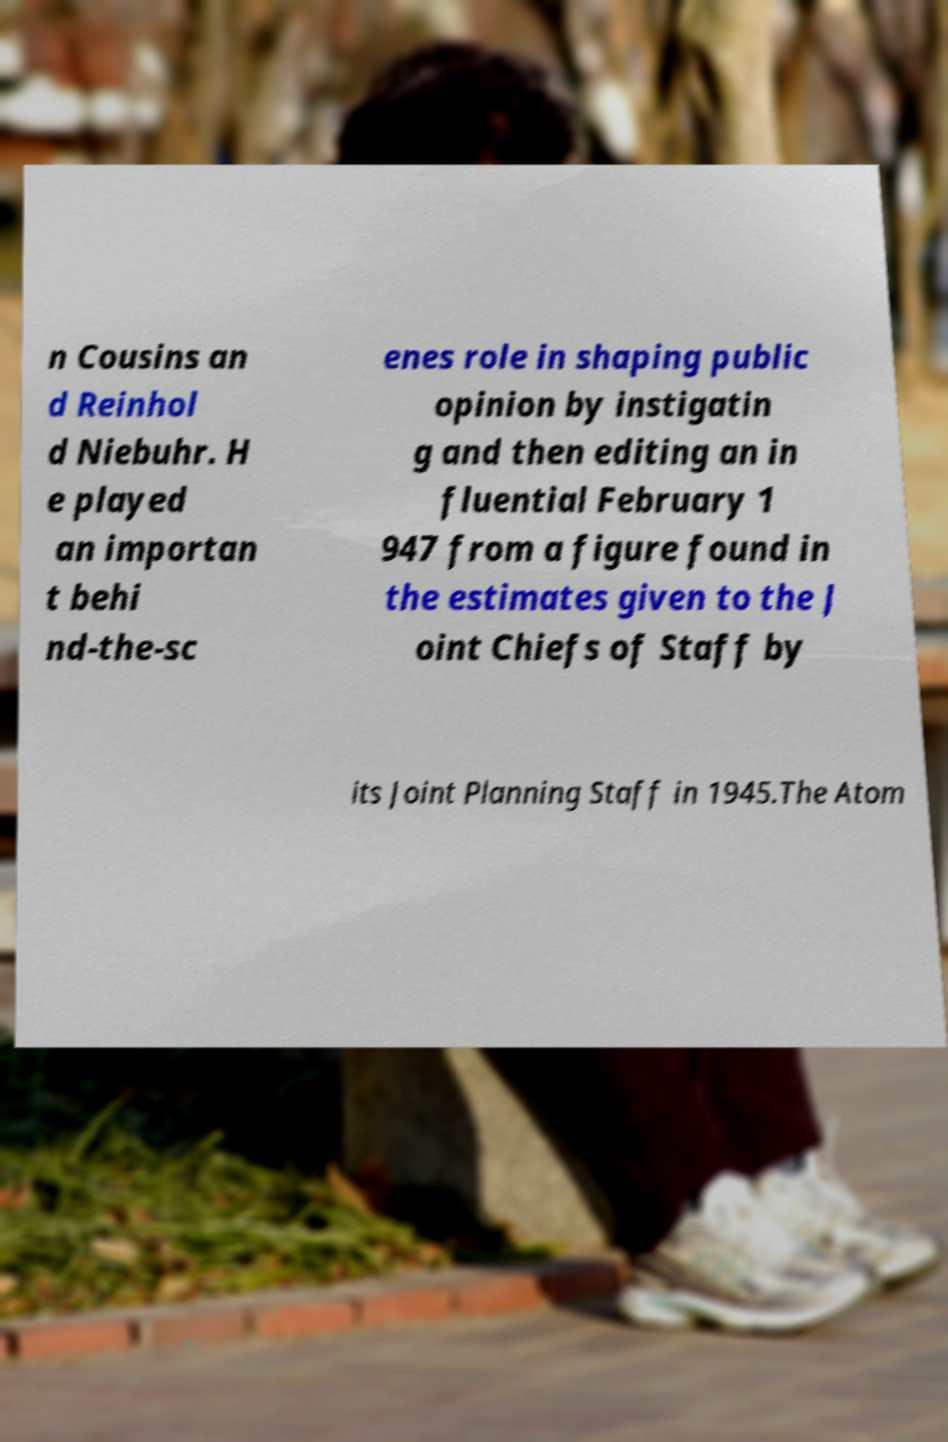I need the written content from this picture converted into text. Can you do that? n Cousins an d Reinhol d Niebuhr. H e played an importan t behi nd-the-sc enes role in shaping public opinion by instigatin g and then editing an in fluential February 1 947 from a figure found in the estimates given to the J oint Chiefs of Staff by its Joint Planning Staff in 1945.The Atom 